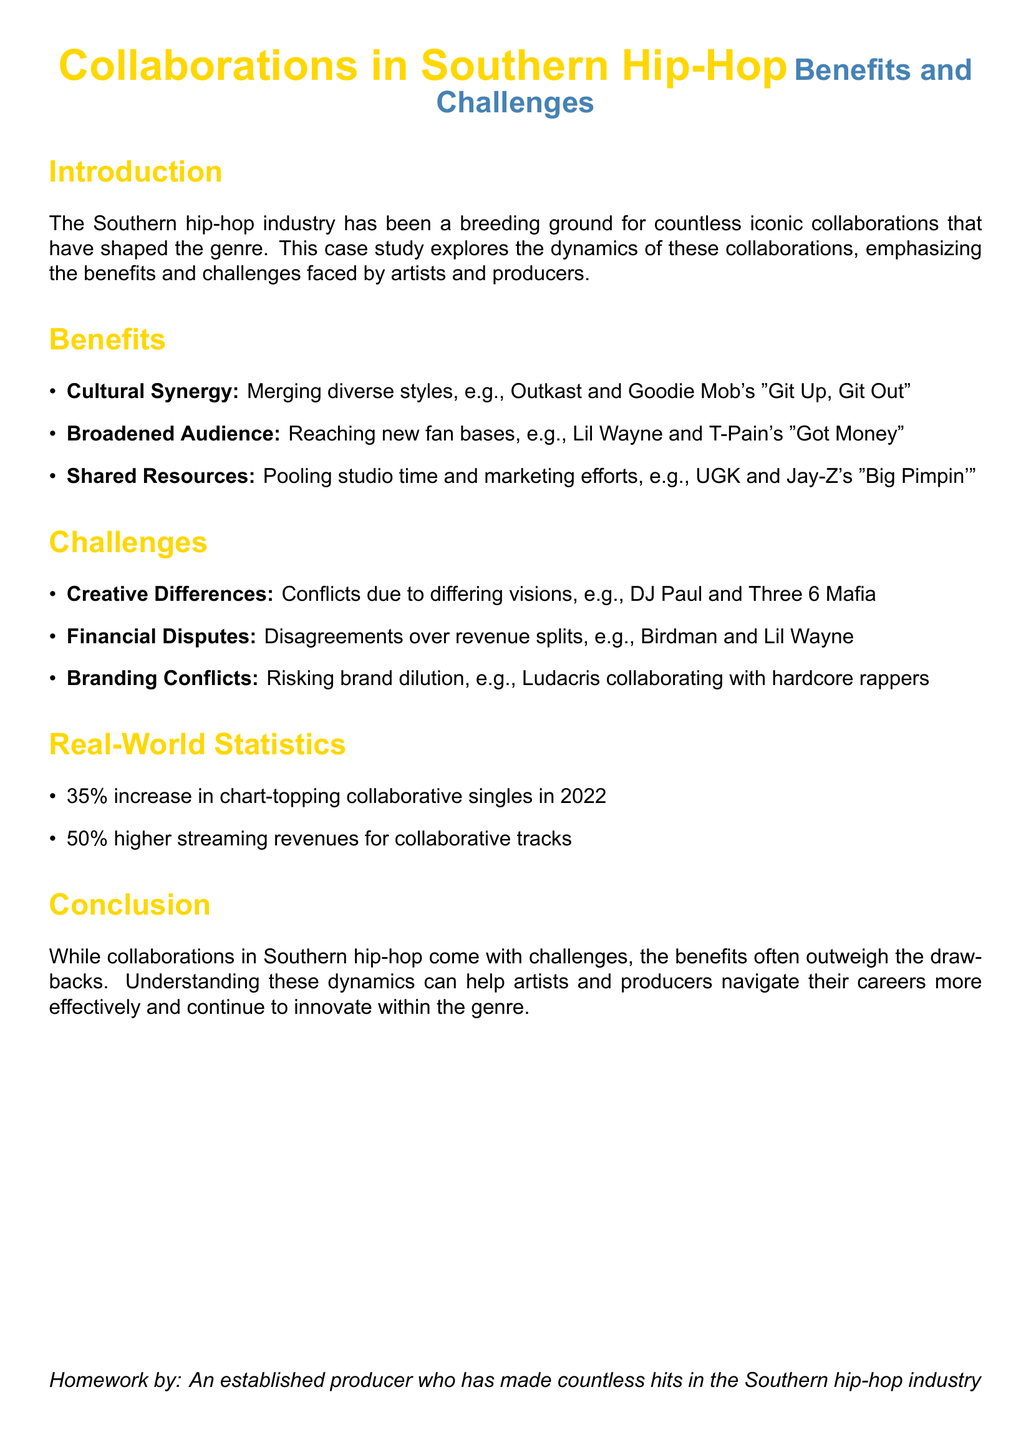what is the title of the document? The title of the document is indicated prominently at the top, emphasizing the focus on Southern hip-hop collaborations.
Answer: Collaborations in Southern Hip-Hop what are two benefits of collaborations mentioned? The document lists three benefits of collaborations, highlighting cultural synergy and broadened audience as key advantages.
Answer: Cultural Synergy, Broadened Audience what is an example of a collaboration increasing audience reach? The document provides a specific example of a collaboration that successfully reached new fan bases in the Southern hip-hop scene.
Answer: Lil Wayne and T-Pain's "Got Money" what percentage increase in chart-topping collaborative singles was noted in 2022? The statistics section of the document reveals significant growth in collaborative singles, indicating stronger trends in the industry.
Answer: 35% what is one challenge of collaboration mentioned in the document? The document identifies several challenges, including creative differences, financial disputes, and branding conflicts.
Answer: Creative Differences what is the higher percentage of streaming revenues for collaborative tracks? The document states the exact percentage increase in streaming revenues attributed to collaborative tracks, showcasing their financial impact.
Answer: 50% who are the two artists mentioned in the example regarding financial disputes? The document gives a specific example of a financial dispute involving well-known figures in the Southern hip-hop community.
Answer: Birdman and Lil Wayne which duo is cited as an example of cultural synergy? The document references a specific collaboration that exemplifies the blending of different cultural styles within Southern hip-hop.
Answer: Outkast and Goodie Mob what kind of conflicts are mentioned as challenges in collaborations? The document lists various types of conflicts that can hinder successful collaborations between artists and producers.
Answer: Creative Differences 